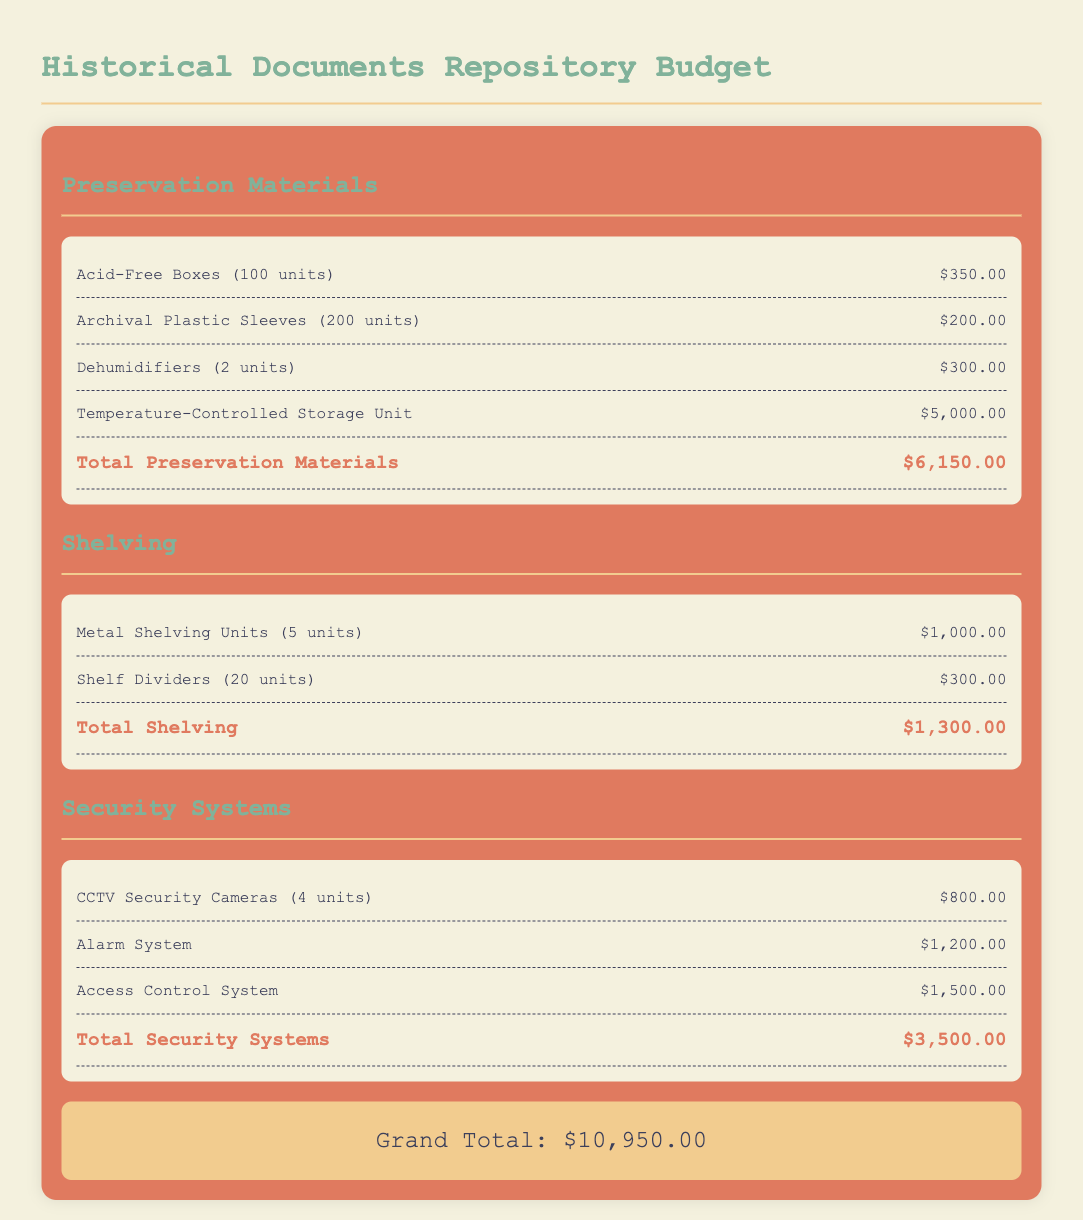What is the total cost for preservation materials? The total cost for preservation materials is clearly stated at the bottom of the section, which adds up to $6,150.00.
Answer: $6,150.00 What is the cost of the Temperature-Controlled Storage Unit? The document lists the Temperature-Controlled Storage Unit as a specific item with a cost provided, which is $5,000.00.
Answer: $5,000.00 How many CCTV Security Cameras are included in the budget? The budget specifies the number of CCTV Security Cameras as four units under the Security Systems section.
Answer: 4 What is the total cost for shelving? The total cost for shelving is summarized at the end of that section, which comes to $1,300.00.
Answer: $1,300.00 What is the grand total of the inventory management budget? The grand total is the sum of all sections of the budget, which is stated as $10,950.00 at the bottom of the document.
Answer: $10,950.00 How many units of Archival Plastic Sleeves are budgeted? The document indicates that there are 200 units of Archival Plastic Sleeves included in the budget.
Answer: 200 What is the cost of the Access Control System? The budget lists the Access Control System as a specific item with a cost provided, which is $1,500.00.
Answer: $1,500.00 What type of shelving units are included in the budget? The budget specifies that the shelving units are Metal Shelving Units.
Answer: Metal Shelving Units What is the total cost allocated for security systems? The total cost for security systems is detailed at the end of that section, amounting to $3,500.00.
Answer: $3,500.00 